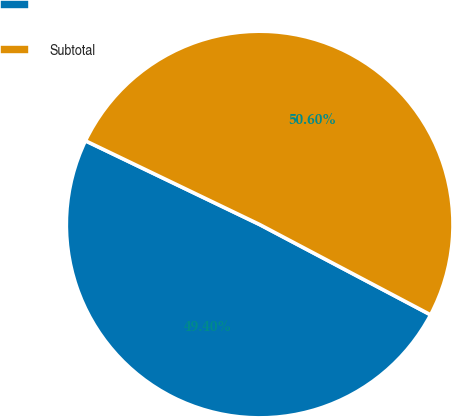<chart> <loc_0><loc_0><loc_500><loc_500><pie_chart><ecel><fcel>Subtotal<nl><fcel>49.4%<fcel>50.6%<nl></chart> 